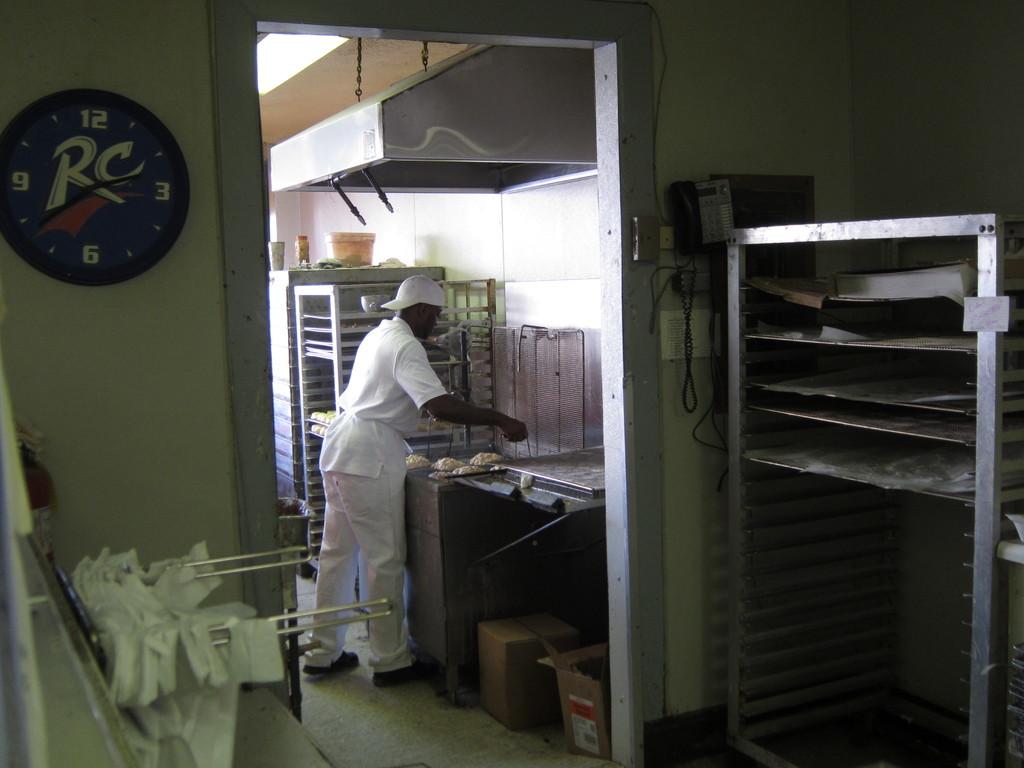Is that an rc clock?
Your response must be concise. Yes. What time is on the clock?
Make the answer very short. 2:39. 